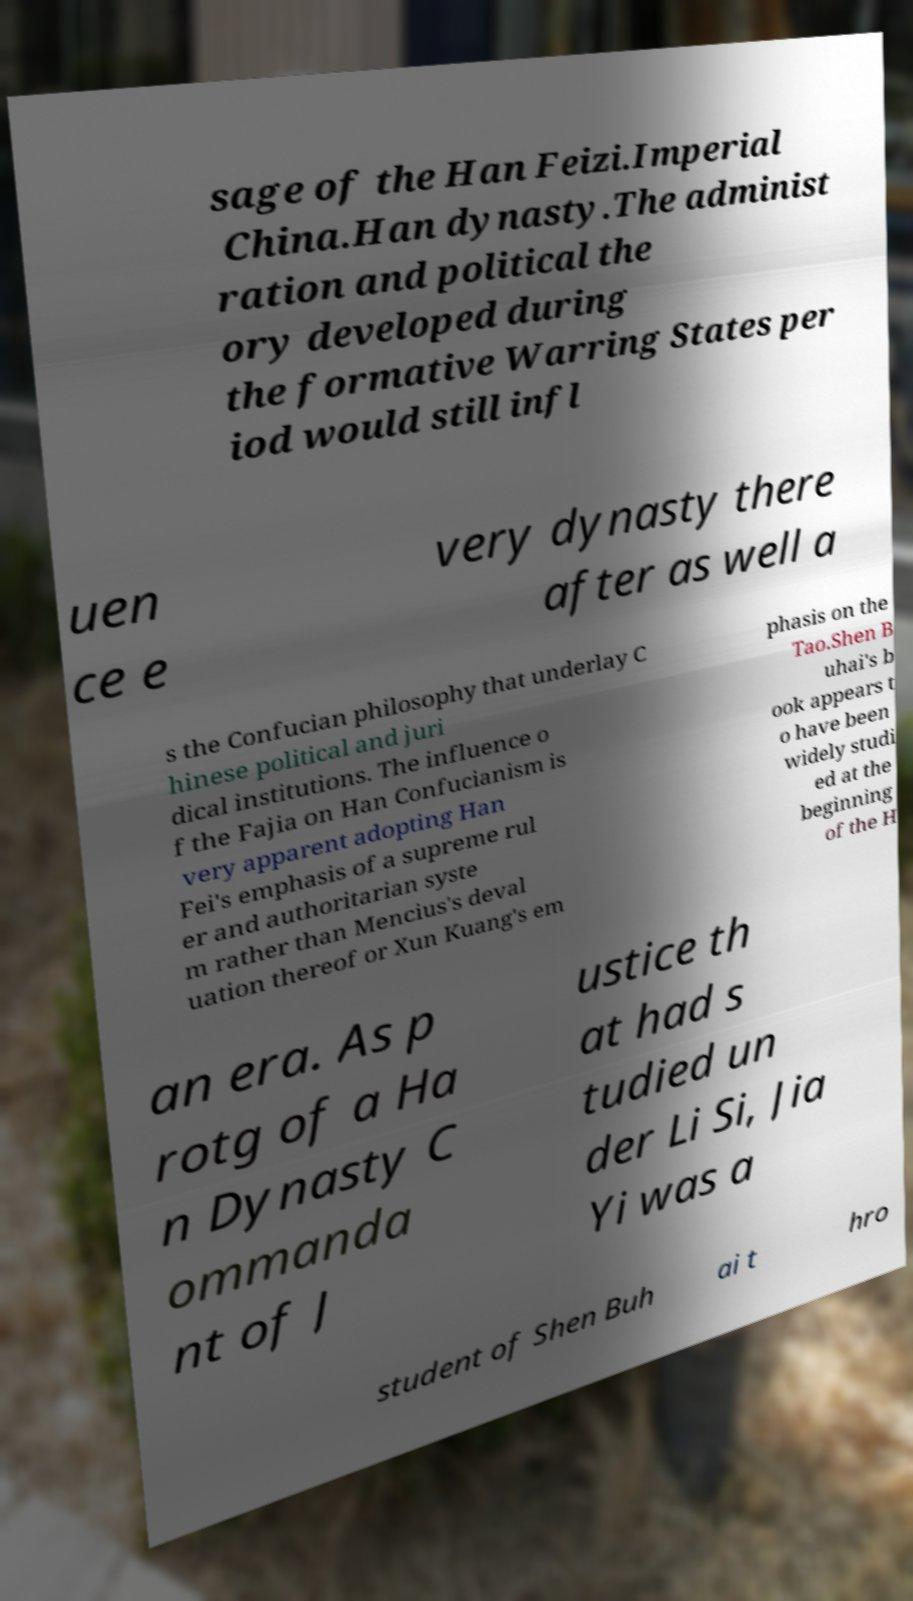I need the written content from this picture converted into text. Can you do that? sage of the Han Feizi.Imperial China.Han dynasty.The administ ration and political the ory developed during the formative Warring States per iod would still infl uen ce e very dynasty there after as well a s the Confucian philosophy that underlay C hinese political and juri dical institutions. The influence o f the Fajia on Han Confucianism is very apparent adopting Han Fei's emphasis of a supreme rul er and authoritarian syste m rather than Mencius's deval uation thereof or Xun Kuang's em phasis on the Tao.Shen B uhai's b ook appears t o have been widely studi ed at the beginning of the H an era. As p rotg of a Ha n Dynasty C ommanda nt of J ustice th at had s tudied un der Li Si, Jia Yi was a student of Shen Buh ai t hro 